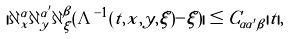Convert formula to latex. <formula><loc_0><loc_0><loc_500><loc_500>| \partial ^ { \alpha } _ { x } \partial ^ { \alpha ^ { \prime } } _ { y } \partial ^ { \beta } _ { \xi } ( \Lambda ^ { - 1 } ( t , x , y , \xi ) - \xi ) | \leq C _ { \alpha \alpha ^ { \prime } \beta } | t | ,</formula> 